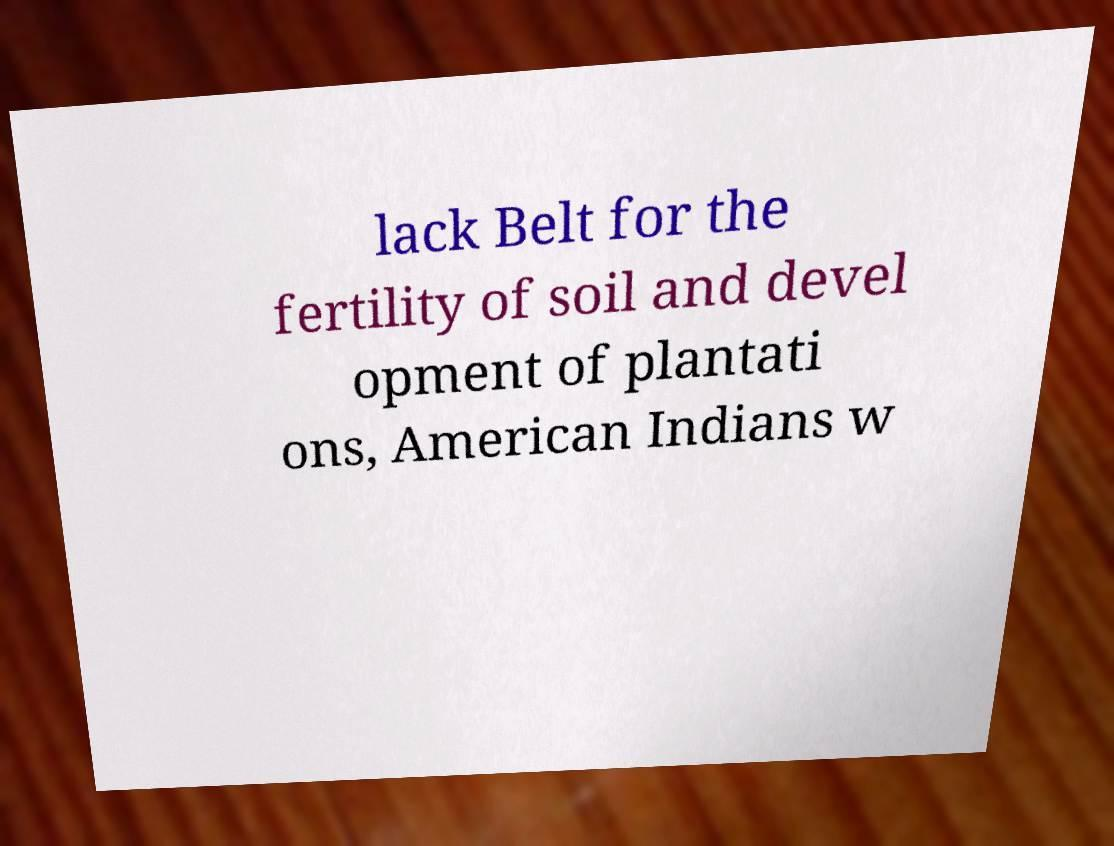Could you assist in decoding the text presented in this image and type it out clearly? lack Belt for the fertility of soil and devel opment of plantati ons, American Indians w 